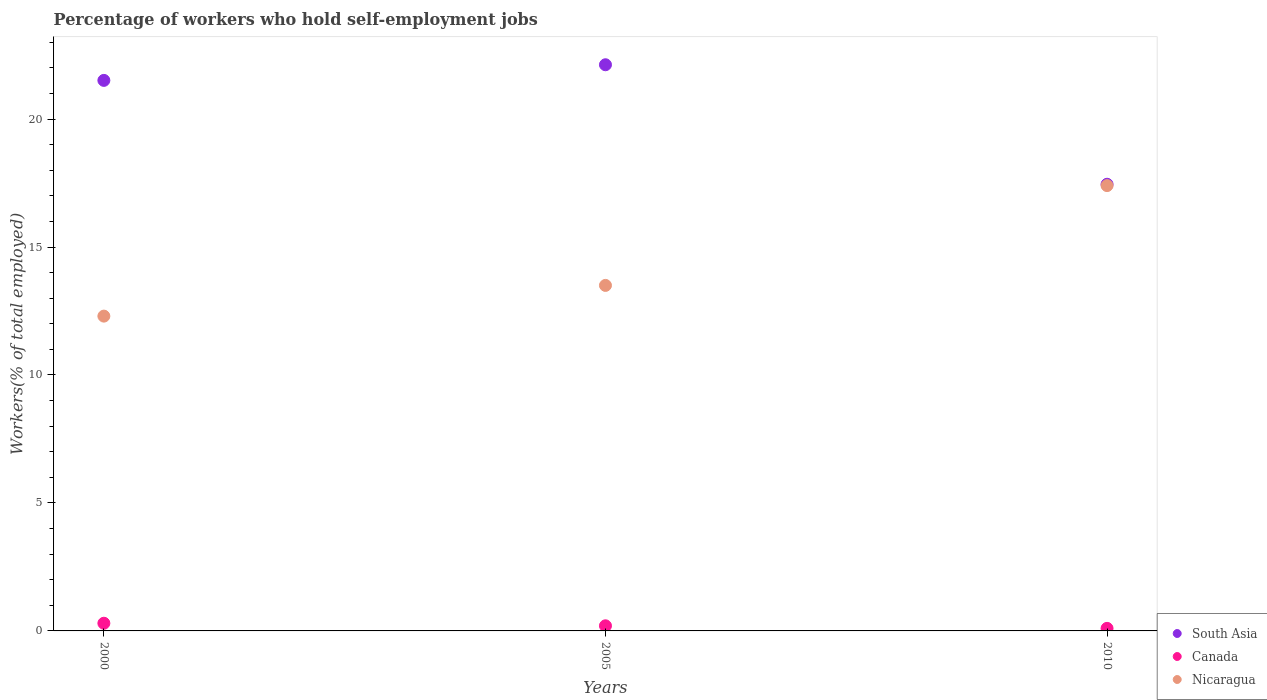How many different coloured dotlines are there?
Your response must be concise. 3. What is the percentage of self-employed workers in Nicaragua in 2000?
Your answer should be compact. 12.3. Across all years, what is the maximum percentage of self-employed workers in Nicaragua?
Ensure brevity in your answer.  17.4. Across all years, what is the minimum percentage of self-employed workers in Nicaragua?
Ensure brevity in your answer.  12.3. What is the total percentage of self-employed workers in South Asia in the graph?
Ensure brevity in your answer.  61.08. What is the difference between the percentage of self-employed workers in South Asia in 2000 and that in 2010?
Make the answer very short. 4.06. What is the difference between the percentage of self-employed workers in Nicaragua in 2000 and the percentage of self-employed workers in South Asia in 2005?
Offer a very short reply. -9.82. What is the average percentage of self-employed workers in South Asia per year?
Keep it short and to the point. 20.36. In the year 2005, what is the difference between the percentage of self-employed workers in Canada and percentage of self-employed workers in South Asia?
Keep it short and to the point. -21.92. What is the ratio of the percentage of self-employed workers in Canada in 2000 to that in 2005?
Give a very brief answer. 1.5. Is the difference between the percentage of self-employed workers in Canada in 2000 and 2010 greater than the difference between the percentage of self-employed workers in South Asia in 2000 and 2010?
Your answer should be very brief. No. What is the difference between the highest and the second highest percentage of self-employed workers in Nicaragua?
Your response must be concise. 3.9. What is the difference between the highest and the lowest percentage of self-employed workers in Canada?
Provide a short and direct response. 0.2. In how many years, is the percentage of self-employed workers in South Asia greater than the average percentage of self-employed workers in South Asia taken over all years?
Your answer should be very brief. 2. Is the percentage of self-employed workers in South Asia strictly less than the percentage of self-employed workers in Canada over the years?
Ensure brevity in your answer.  No. How many dotlines are there?
Provide a short and direct response. 3. How many years are there in the graph?
Give a very brief answer. 3. What is the title of the graph?
Ensure brevity in your answer.  Percentage of workers who hold self-employment jobs. What is the label or title of the Y-axis?
Your response must be concise. Workers(% of total employed). What is the Workers(% of total employed) of South Asia in 2000?
Offer a very short reply. 21.51. What is the Workers(% of total employed) in Canada in 2000?
Make the answer very short. 0.3. What is the Workers(% of total employed) of Nicaragua in 2000?
Provide a short and direct response. 12.3. What is the Workers(% of total employed) of South Asia in 2005?
Give a very brief answer. 22.12. What is the Workers(% of total employed) in Canada in 2005?
Make the answer very short. 0.2. What is the Workers(% of total employed) in South Asia in 2010?
Offer a very short reply. 17.45. What is the Workers(% of total employed) in Canada in 2010?
Your response must be concise. 0.1. What is the Workers(% of total employed) in Nicaragua in 2010?
Keep it short and to the point. 17.4. Across all years, what is the maximum Workers(% of total employed) in South Asia?
Your answer should be very brief. 22.12. Across all years, what is the maximum Workers(% of total employed) in Canada?
Give a very brief answer. 0.3. Across all years, what is the maximum Workers(% of total employed) in Nicaragua?
Your response must be concise. 17.4. Across all years, what is the minimum Workers(% of total employed) of South Asia?
Make the answer very short. 17.45. Across all years, what is the minimum Workers(% of total employed) in Canada?
Give a very brief answer. 0.1. Across all years, what is the minimum Workers(% of total employed) in Nicaragua?
Provide a succinct answer. 12.3. What is the total Workers(% of total employed) of South Asia in the graph?
Keep it short and to the point. 61.08. What is the total Workers(% of total employed) in Nicaragua in the graph?
Offer a terse response. 43.2. What is the difference between the Workers(% of total employed) in South Asia in 2000 and that in 2005?
Your response must be concise. -0.61. What is the difference between the Workers(% of total employed) of Canada in 2000 and that in 2005?
Offer a terse response. 0.1. What is the difference between the Workers(% of total employed) in Nicaragua in 2000 and that in 2005?
Ensure brevity in your answer.  -1.2. What is the difference between the Workers(% of total employed) of South Asia in 2000 and that in 2010?
Your answer should be very brief. 4.06. What is the difference between the Workers(% of total employed) of South Asia in 2005 and that in 2010?
Your answer should be very brief. 4.67. What is the difference between the Workers(% of total employed) of South Asia in 2000 and the Workers(% of total employed) of Canada in 2005?
Give a very brief answer. 21.31. What is the difference between the Workers(% of total employed) of South Asia in 2000 and the Workers(% of total employed) of Nicaragua in 2005?
Your answer should be compact. 8.01. What is the difference between the Workers(% of total employed) of South Asia in 2000 and the Workers(% of total employed) of Canada in 2010?
Your response must be concise. 21.41. What is the difference between the Workers(% of total employed) in South Asia in 2000 and the Workers(% of total employed) in Nicaragua in 2010?
Your response must be concise. 4.11. What is the difference between the Workers(% of total employed) of Canada in 2000 and the Workers(% of total employed) of Nicaragua in 2010?
Provide a succinct answer. -17.1. What is the difference between the Workers(% of total employed) in South Asia in 2005 and the Workers(% of total employed) in Canada in 2010?
Ensure brevity in your answer.  22.02. What is the difference between the Workers(% of total employed) in South Asia in 2005 and the Workers(% of total employed) in Nicaragua in 2010?
Make the answer very short. 4.72. What is the difference between the Workers(% of total employed) of Canada in 2005 and the Workers(% of total employed) of Nicaragua in 2010?
Your answer should be very brief. -17.2. What is the average Workers(% of total employed) in South Asia per year?
Provide a short and direct response. 20.36. In the year 2000, what is the difference between the Workers(% of total employed) of South Asia and Workers(% of total employed) of Canada?
Your response must be concise. 21.21. In the year 2000, what is the difference between the Workers(% of total employed) in South Asia and Workers(% of total employed) in Nicaragua?
Give a very brief answer. 9.21. In the year 2000, what is the difference between the Workers(% of total employed) of Canada and Workers(% of total employed) of Nicaragua?
Provide a short and direct response. -12. In the year 2005, what is the difference between the Workers(% of total employed) of South Asia and Workers(% of total employed) of Canada?
Offer a terse response. 21.92. In the year 2005, what is the difference between the Workers(% of total employed) in South Asia and Workers(% of total employed) in Nicaragua?
Provide a succinct answer. 8.62. In the year 2005, what is the difference between the Workers(% of total employed) of Canada and Workers(% of total employed) of Nicaragua?
Your answer should be compact. -13.3. In the year 2010, what is the difference between the Workers(% of total employed) of South Asia and Workers(% of total employed) of Canada?
Provide a short and direct response. 17.35. In the year 2010, what is the difference between the Workers(% of total employed) in South Asia and Workers(% of total employed) in Nicaragua?
Keep it short and to the point. 0.05. In the year 2010, what is the difference between the Workers(% of total employed) in Canada and Workers(% of total employed) in Nicaragua?
Give a very brief answer. -17.3. What is the ratio of the Workers(% of total employed) in South Asia in 2000 to that in 2005?
Ensure brevity in your answer.  0.97. What is the ratio of the Workers(% of total employed) of Canada in 2000 to that in 2005?
Ensure brevity in your answer.  1.5. What is the ratio of the Workers(% of total employed) in Nicaragua in 2000 to that in 2005?
Keep it short and to the point. 0.91. What is the ratio of the Workers(% of total employed) in South Asia in 2000 to that in 2010?
Provide a short and direct response. 1.23. What is the ratio of the Workers(% of total employed) in Canada in 2000 to that in 2010?
Ensure brevity in your answer.  3. What is the ratio of the Workers(% of total employed) in Nicaragua in 2000 to that in 2010?
Your response must be concise. 0.71. What is the ratio of the Workers(% of total employed) in South Asia in 2005 to that in 2010?
Offer a very short reply. 1.27. What is the ratio of the Workers(% of total employed) in Canada in 2005 to that in 2010?
Provide a short and direct response. 2. What is the ratio of the Workers(% of total employed) in Nicaragua in 2005 to that in 2010?
Provide a succinct answer. 0.78. What is the difference between the highest and the second highest Workers(% of total employed) of South Asia?
Offer a very short reply. 0.61. What is the difference between the highest and the second highest Workers(% of total employed) in Canada?
Provide a short and direct response. 0.1. What is the difference between the highest and the lowest Workers(% of total employed) of South Asia?
Your answer should be very brief. 4.67. What is the difference between the highest and the lowest Workers(% of total employed) in Canada?
Provide a short and direct response. 0.2. 